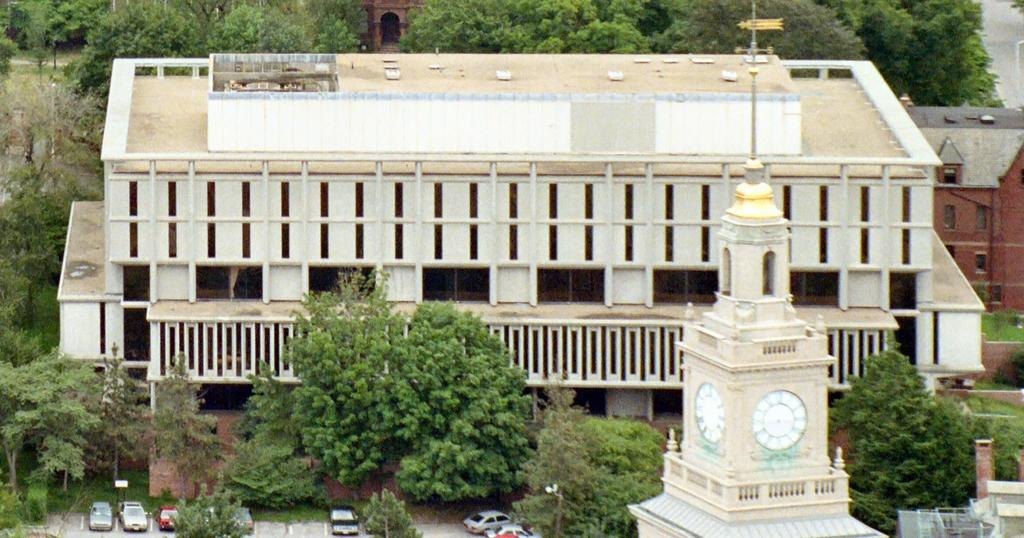What can be seen moving on the road in the image? There are vehicles on the road in the image. What time-related objects are attached to the tower? Two clocks are attached to the wall of a tower. What type of natural scenery is visible in the background of the image? There are trees in the background of the image. What type of man-made structures can be seen in the background of the image? There are buildings in the background of the image. Where is another road visible in the image? There is a road visible at the top right of the image. What type of comb is used to shock the riddle in the image? There is no comb, shock, or riddle present in the image. 